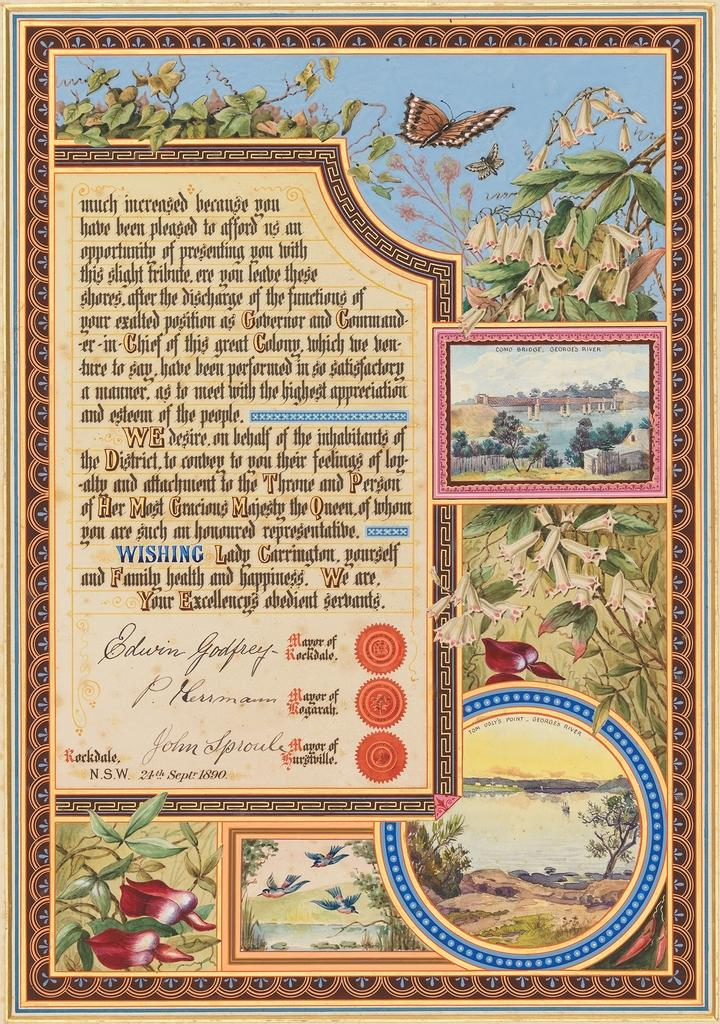Provide a one-sentence caption for the provided image. A painting on the poster shows Como Bridge over Georges River. 